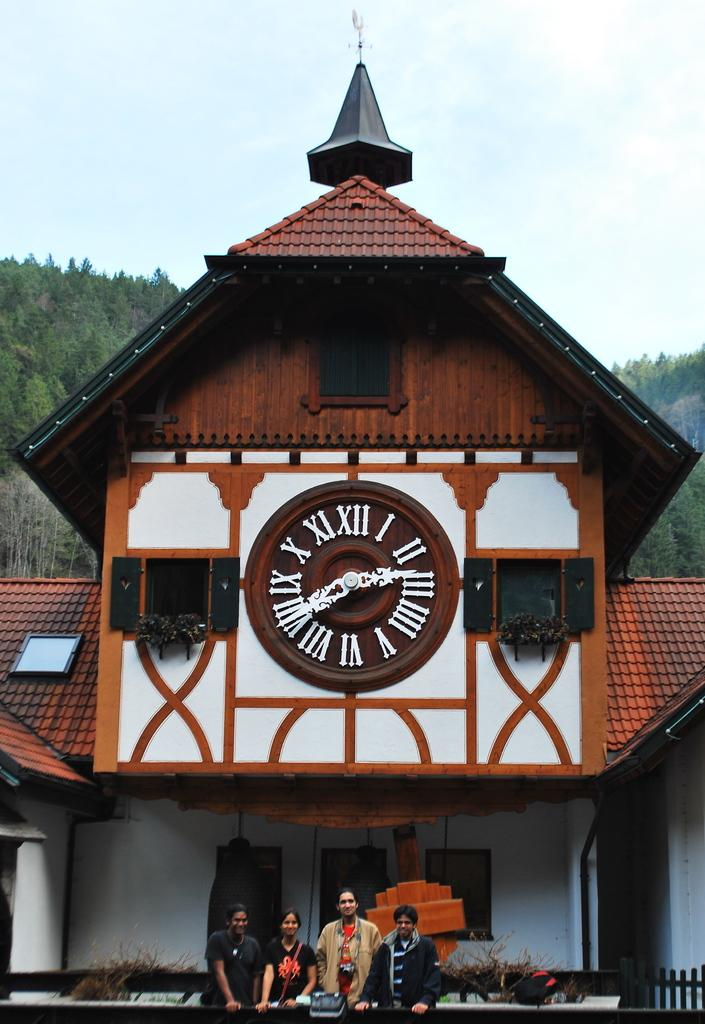<image>
Offer a succinct explanation of the picture presented. People are standing in front of a building with a clock on it that shows the time 2:41. 